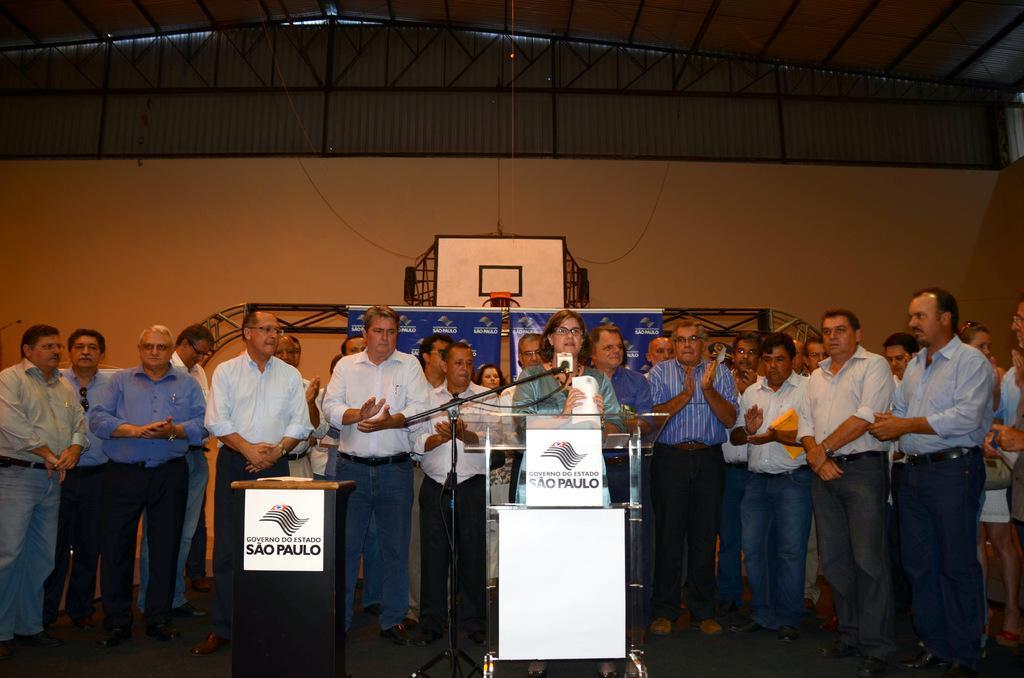In one or two sentences, can you explain what this image depicts? In this image in the center there are group of persons standing. In the front there is a woman standing and speaking. In front of the woman there is a mic there is a podium with some text written on it. In the background there is a banner with some text written on it which is blue in colour and there is a basketball net and there is a tin shed on the top. 